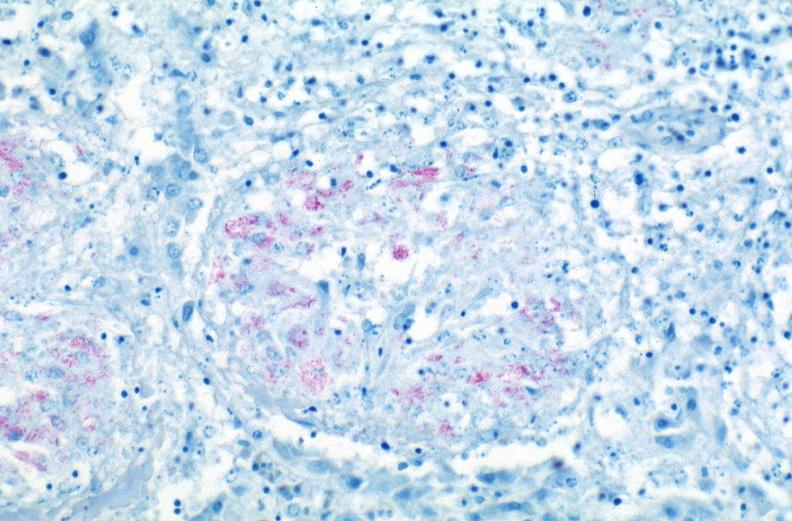what is present?
Answer the question using a single word or phrase. Respiratory 